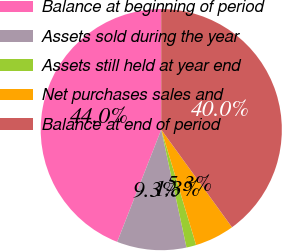Convert chart to OTSL. <chart><loc_0><loc_0><loc_500><loc_500><pie_chart><fcel>Balance at beginning of period<fcel>Assets sold during the year<fcel>Assets still held at year end<fcel>Net purchases sales and<fcel>Balance at end of period<nl><fcel>44.04%<fcel>9.31%<fcel>1.31%<fcel>5.31%<fcel>40.03%<nl></chart> 